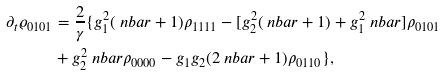<formula> <loc_0><loc_0><loc_500><loc_500>\partial _ { t } { \varrho _ { 0 1 0 1 } } & = \frac { 2 } { \gamma } \{ g _ { 1 } ^ { 2 } ( \ n b a r + 1 ) \rho _ { 1 1 1 1 } - [ g _ { 2 } ^ { 2 } ( \ n b a r + 1 ) + g _ { 1 } ^ { 2 } \ n b a r ] \rho _ { 0 1 0 1 } \\ & + g _ { 2 } ^ { 2 } \ n b a r \rho _ { 0 0 0 0 } - g _ { 1 } g _ { 2 } ( 2 \ n b a r + 1 ) \rho _ { 0 1 1 0 } \} ,</formula> 